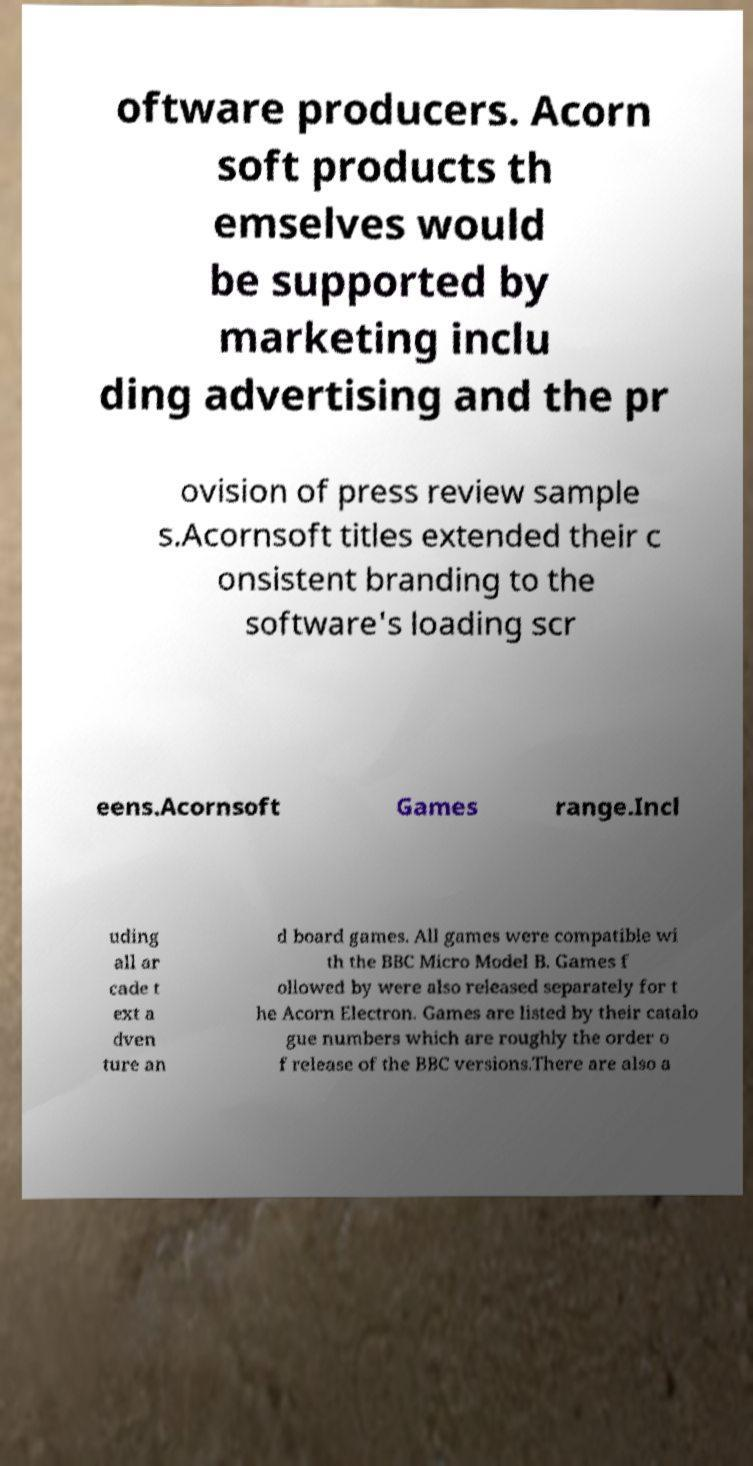I need the written content from this picture converted into text. Can you do that? oftware producers. Acorn soft products th emselves would be supported by marketing inclu ding advertising and the pr ovision of press review sample s.Acornsoft titles extended their c onsistent branding to the software's loading scr eens.Acornsoft Games range.Incl uding all ar cade t ext a dven ture an d board games. All games were compatible wi th the BBC Micro Model B. Games f ollowed by were also released separately for t he Acorn Electron. Games are listed by their catalo gue numbers which are roughly the order o f release of the BBC versions.There are also a 